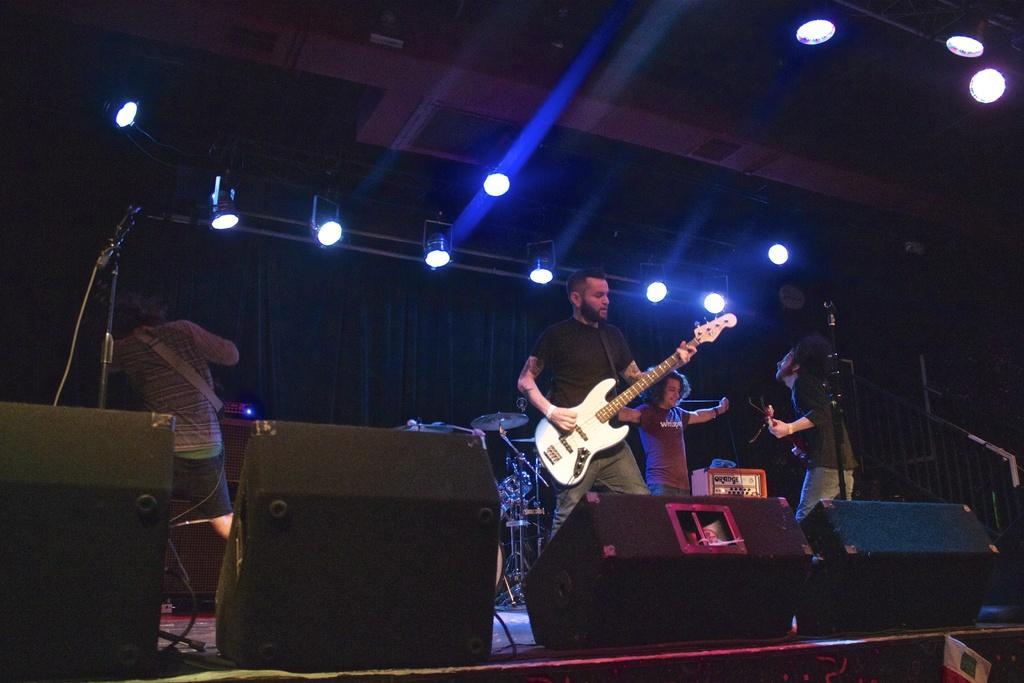In one or two sentences, can you explain what this image depicts? This image is clicked in a musical concert. There are lights on the top, there are lights on the right side corner. There is person in the middle of the image who is playing a guitar. he is wearing black shirt. Other two persons who are standing beside him are also smiling and the person on the left side is standing and there is a mic on the left side. There are stairs on the right side bottom corner. There are drums in the middle of the image 